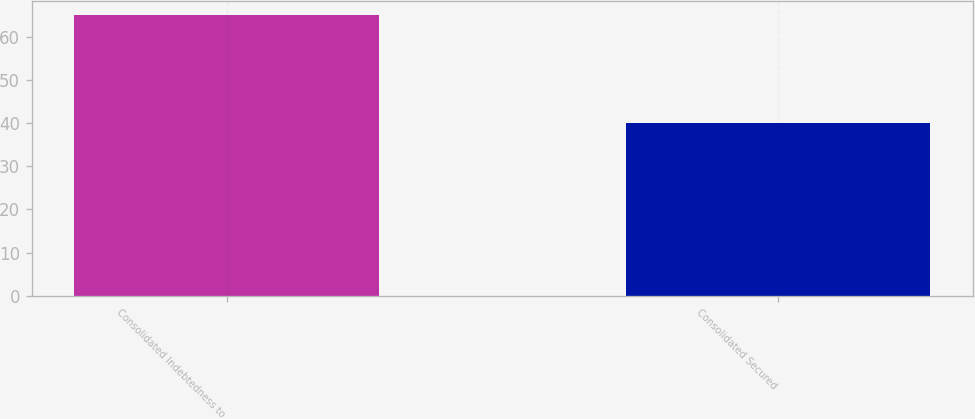Convert chart to OTSL. <chart><loc_0><loc_0><loc_500><loc_500><bar_chart><fcel>Consolidated Indebtedness to<fcel>Consolidated Secured<nl><fcel>65<fcel>40<nl></chart> 